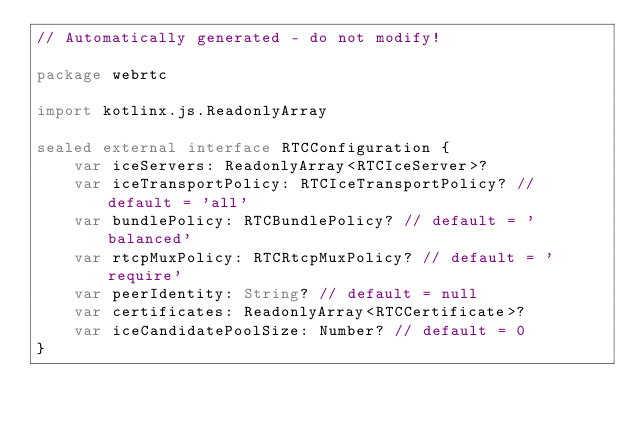<code> <loc_0><loc_0><loc_500><loc_500><_Kotlin_>// Automatically generated - do not modify!

package webrtc

import kotlinx.js.ReadonlyArray

sealed external interface RTCConfiguration {
    var iceServers: ReadonlyArray<RTCIceServer>?
    var iceTransportPolicy: RTCIceTransportPolicy? // default = 'all'
    var bundlePolicy: RTCBundlePolicy? // default = 'balanced'
    var rtcpMuxPolicy: RTCRtcpMuxPolicy? // default = 'require'
    var peerIdentity: String? // default = null
    var certificates: ReadonlyArray<RTCCertificate>?
    var iceCandidatePoolSize: Number? // default = 0
}
</code> 